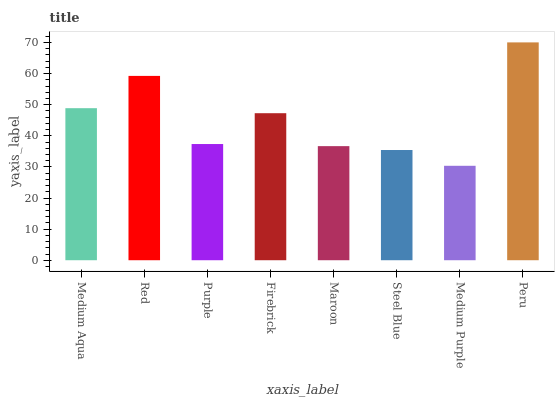Is Medium Purple the minimum?
Answer yes or no. Yes. Is Peru the maximum?
Answer yes or no. Yes. Is Red the minimum?
Answer yes or no. No. Is Red the maximum?
Answer yes or no. No. Is Red greater than Medium Aqua?
Answer yes or no. Yes. Is Medium Aqua less than Red?
Answer yes or no. Yes. Is Medium Aqua greater than Red?
Answer yes or no. No. Is Red less than Medium Aqua?
Answer yes or no. No. Is Firebrick the high median?
Answer yes or no. Yes. Is Purple the low median?
Answer yes or no. Yes. Is Purple the high median?
Answer yes or no. No. Is Medium Aqua the low median?
Answer yes or no. No. 